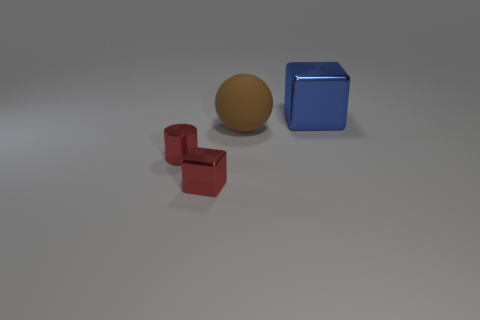There is a big object in front of the big metal object; is it the same shape as the small red metallic thing that is on the right side of the metallic cylinder?
Provide a short and direct response. No. How many things are either rubber things or red matte cylinders?
Your answer should be very brief. 1. There is a metallic block that is the same size as the brown matte ball; what color is it?
Offer a terse response. Blue. There is a tiny metal thing left of the tiny red cube; what number of small red things are in front of it?
Offer a terse response. 1. How many metal things are both on the right side of the red shiny cylinder and in front of the large matte object?
Provide a short and direct response. 1. What number of things are either small things that are to the right of the red metal cylinder or shiny things that are behind the tiny cylinder?
Give a very brief answer. 2. How many other things are there of the same size as the cylinder?
Offer a terse response. 1. There is a small red metal thing left of the shiny cube that is in front of the large metallic block; what shape is it?
Offer a very short reply. Cylinder. There is a small metallic thing that is on the right side of the shiny cylinder; is its color the same as the metal block that is on the right side of the small metal block?
Offer a terse response. No. Is there anything else that has the same color as the big shiny thing?
Your answer should be compact. No. 